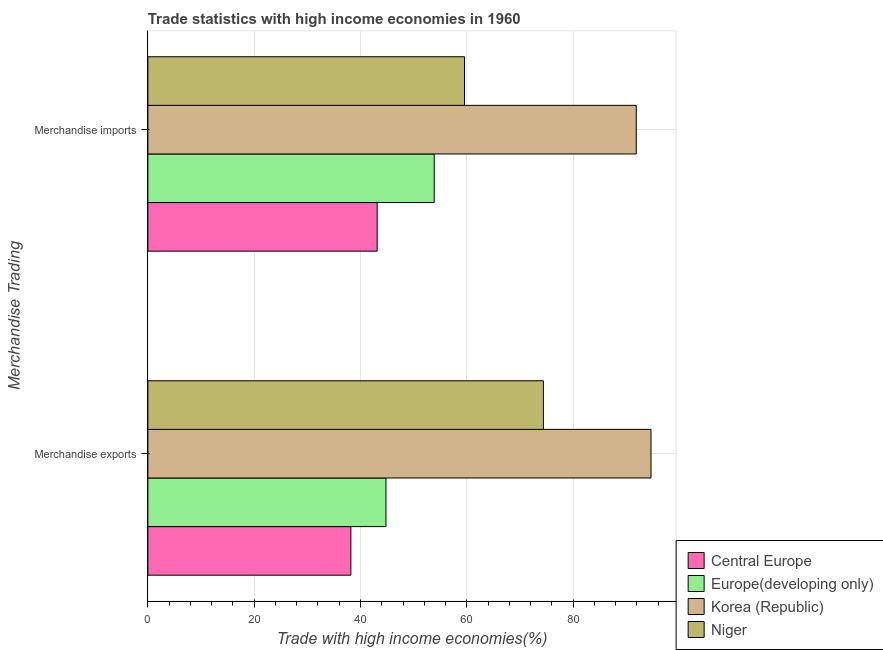How many different coloured bars are there?
Ensure brevity in your answer.  4. How many groups of bars are there?
Keep it short and to the point. 2. Are the number of bars per tick equal to the number of legend labels?
Give a very brief answer. Yes. Are the number of bars on each tick of the Y-axis equal?
Offer a terse response. Yes. How many bars are there on the 2nd tick from the top?
Give a very brief answer. 4. How many bars are there on the 1st tick from the bottom?
Give a very brief answer. 4. What is the merchandise exports in Niger?
Your answer should be very brief. 74.4. Across all countries, what is the maximum merchandise exports?
Provide a short and direct response. 94.64. Across all countries, what is the minimum merchandise imports?
Provide a short and direct response. 43.13. In which country was the merchandise exports minimum?
Give a very brief answer. Central Europe. What is the total merchandise imports in the graph?
Make the answer very short. 248.42. What is the difference between the merchandise imports in Central Europe and that in Europe(developing only)?
Offer a very short reply. -10.73. What is the difference between the merchandise imports in Central Europe and the merchandise exports in Korea (Republic)?
Provide a short and direct response. -51.51. What is the average merchandise exports per country?
Offer a very short reply. 63. What is the difference between the merchandise exports and merchandise imports in Europe(developing only)?
Give a very brief answer. -9.08. What is the ratio of the merchandise imports in Central Europe to that in Europe(developing only)?
Your answer should be very brief. 0.8. What does the 1st bar from the top in Merchandise exports represents?
Your answer should be very brief. Niger. What does the 1st bar from the bottom in Merchandise exports represents?
Give a very brief answer. Central Europe. How many countries are there in the graph?
Offer a terse response. 4. Does the graph contain any zero values?
Offer a terse response. No. How are the legend labels stacked?
Provide a succinct answer. Vertical. What is the title of the graph?
Make the answer very short. Trade statistics with high income economies in 1960. What is the label or title of the X-axis?
Ensure brevity in your answer.  Trade with high income economies(%). What is the label or title of the Y-axis?
Your response must be concise. Merchandise Trading. What is the Trade with high income economies(%) of Central Europe in Merchandise exports?
Your response must be concise. 38.19. What is the Trade with high income economies(%) of Europe(developing only) in Merchandise exports?
Give a very brief answer. 44.79. What is the Trade with high income economies(%) of Korea (Republic) in Merchandise exports?
Make the answer very short. 94.64. What is the Trade with high income economies(%) of Niger in Merchandise exports?
Give a very brief answer. 74.4. What is the Trade with high income economies(%) of Central Europe in Merchandise imports?
Give a very brief answer. 43.13. What is the Trade with high income economies(%) in Europe(developing only) in Merchandise imports?
Your answer should be compact. 53.86. What is the Trade with high income economies(%) in Korea (Republic) in Merchandise imports?
Offer a very short reply. 91.87. What is the Trade with high income economies(%) in Niger in Merchandise imports?
Make the answer very short. 59.56. Across all Merchandise Trading, what is the maximum Trade with high income economies(%) in Central Europe?
Give a very brief answer. 43.13. Across all Merchandise Trading, what is the maximum Trade with high income economies(%) of Europe(developing only)?
Make the answer very short. 53.86. Across all Merchandise Trading, what is the maximum Trade with high income economies(%) of Korea (Republic)?
Give a very brief answer. 94.64. Across all Merchandise Trading, what is the maximum Trade with high income economies(%) in Niger?
Provide a short and direct response. 74.4. Across all Merchandise Trading, what is the minimum Trade with high income economies(%) of Central Europe?
Ensure brevity in your answer.  38.19. Across all Merchandise Trading, what is the minimum Trade with high income economies(%) of Europe(developing only)?
Your response must be concise. 44.79. Across all Merchandise Trading, what is the minimum Trade with high income economies(%) of Korea (Republic)?
Provide a succinct answer. 91.87. Across all Merchandise Trading, what is the minimum Trade with high income economies(%) of Niger?
Your answer should be compact. 59.56. What is the total Trade with high income economies(%) in Central Europe in the graph?
Keep it short and to the point. 81.32. What is the total Trade with high income economies(%) of Europe(developing only) in the graph?
Provide a short and direct response. 98.65. What is the total Trade with high income economies(%) in Korea (Republic) in the graph?
Make the answer very short. 186.51. What is the total Trade with high income economies(%) of Niger in the graph?
Your response must be concise. 133.96. What is the difference between the Trade with high income economies(%) in Central Europe in Merchandise exports and that in Merchandise imports?
Ensure brevity in your answer.  -4.94. What is the difference between the Trade with high income economies(%) of Europe(developing only) in Merchandise exports and that in Merchandise imports?
Your answer should be very brief. -9.08. What is the difference between the Trade with high income economies(%) in Korea (Republic) in Merchandise exports and that in Merchandise imports?
Offer a terse response. 2.77. What is the difference between the Trade with high income economies(%) in Niger in Merchandise exports and that in Merchandise imports?
Provide a short and direct response. 14.84. What is the difference between the Trade with high income economies(%) of Central Europe in Merchandise exports and the Trade with high income economies(%) of Europe(developing only) in Merchandise imports?
Keep it short and to the point. -15.68. What is the difference between the Trade with high income economies(%) in Central Europe in Merchandise exports and the Trade with high income economies(%) in Korea (Republic) in Merchandise imports?
Provide a succinct answer. -53.68. What is the difference between the Trade with high income economies(%) in Central Europe in Merchandise exports and the Trade with high income economies(%) in Niger in Merchandise imports?
Offer a terse response. -21.37. What is the difference between the Trade with high income economies(%) of Europe(developing only) in Merchandise exports and the Trade with high income economies(%) of Korea (Republic) in Merchandise imports?
Ensure brevity in your answer.  -47.08. What is the difference between the Trade with high income economies(%) in Europe(developing only) in Merchandise exports and the Trade with high income economies(%) in Niger in Merchandise imports?
Give a very brief answer. -14.77. What is the difference between the Trade with high income economies(%) of Korea (Republic) in Merchandise exports and the Trade with high income economies(%) of Niger in Merchandise imports?
Your answer should be very brief. 35.08. What is the average Trade with high income economies(%) of Central Europe per Merchandise Trading?
Offer a very short reply. 40.66. What is the average Trade with high income economies(%) in Europe(developing only) per Merchandise Trading?
Make the answer very short. 49.33. What is the average Trade with high income economies(%) in Korea (Republic) per Merchandise Trading?
Your response must be concise. 93.25. What is the average Trade with high income economies(%) of Niger per Merchandise Trading?
Your response must be concise. 66.98. What is the difference between the Trade with high income economies(%) in Central Europe and Trade with high income economies(%) in Europe(developing only) in Merchandise exports?
Give a very brief answer. -6.6. What is the difference between the Trade with high income economies(%) in Central Europe and Trade with high income economies(%) in Korea (Republic) in Merchandise exports?
Your answer should be very brief. -56.45. What is the difference between the Trade with high income economies(%) in Central Europe and Trade with high income economies(%) in Niger in Merchandise exports?
Your answer should be very brief. -36.21. What is the difference between the Trade with high income economies(%) of Europe(developing only) and Trade with high income economies(%) of Korea (Republic) in Merchandise exports?
Your response must be concise. -49.85. What is the difference between the Trade with high income economies(%) in Europe(developing only) and Trade with high income economies(%) in Niger in Merchandise exports?
Your answer should be compact. -29.61. What is the difference between the Trade with high income economies(%) in Korea (Republic) and Trade with high income economies(%) in Niger in Merchandise exports?
Provide a short and direct response. 20.24. What is the difference between the Trade with high income economies(%) of Central Europe and Trade with high income economies(%) of Europe(developing only) in Merchandise imports?
Keep it short and to the point. -10.73. What is the difference between the Trade with high income economies(%) of Central Europe and Trade with high income economies(%) of Korea (Republic) in Merchandise imports?
Make the answer very short. -48.74. What is the difference between the Trade with high income economies(%) of Central Europe and Trade with high income economies(%) of Niger in Merchandise imports?
Keep it short and to the point. -16.43. What is the difference between the Trade with high income economies(%) of Europe(developing only) and Trade with high income economies(%) of Korea (Republic) in Merchandise imports?
Provide a succinct answer. -38. What is the difference between the Trade with high income economies(%) in Europe(developing only) and Trade with high income economies(%) in Niger in Merchandise imports?
Keep it short and to the point. -5.69. What is the difference between the Trade with high income economies(%) in Korea (Republic) and Trade with high income economies(%) in Niger in Merchandise imports?
Provide a short and direct response. 32.31. What is the ratio of the Trade with high income economies(%) of Central Europe in Merchandise exports to that in Merchandise imports?
Offer a very short reply. 0.89. What is the ratio of the Trade with high income economies(%) in Europe(developing only) in Merchandise exports to that in Merchandise imports?
Provide a succinct answer. 0.83. What is the ratio of the Trade with high income economies(%) in Korea (Republic) in Merchandise exports to that in Merchandise imports?
Offer a very short reply. 1.03. What is the ratio of the Trade with high income economies(%) in Niger in Merchandise exports to that in Merchandise imports?
Give a very brief answer. 1.25. What is the difference between the highest and the second highest Trade with high income economies(%) of Central Europe?
Offer a very short reply. 4.94. What is the difference between the highest and the second highest Trade with high income economies(%) of Europe(developing only)?
Offer a terse response. 9.08. What is the difference between the highest and the second highest Trade with high income economies(%) in Korea (Republic)?
Make the answer very short. 2.77. What is the difference between the highest and the second highest Trade with high income economies(%) of Niger?
Your answer should be compact. 14.84. What is the difference between the highest and the lowest Trade with high income economies(%) of Central Europe?
Make the answer very short. 4.94. What is the difference between the highest and the lowest Trade with high income economies(%) in Europe(developing only)?
Provide a short and direct response. 9.08. What is the difference between the highest and the lowest Trade with high income economies(%) of Korea (Republic)?
Offer a very short reply. 2.77. What is the difference between the highest and the lowest Trade with high income economies(%) of Niger?
Offer a very short reply. 14.84. 